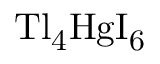Convert formula to latex. <formula><loc_0><loc_0><loc_500><loc_500>T l _ { 4 } H g I _ { 6 }</formula> 